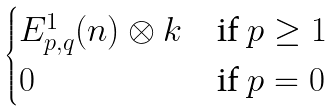<formula> <loc_0><loc_0><loc_500><loc_500>\begin{cases} E _ { p , q } ^ { 1 } ( n ) \otimes k & \text {if $p \geq 1$} \\ 0 & \text {if $p=0$} \end{cases}</formula> 